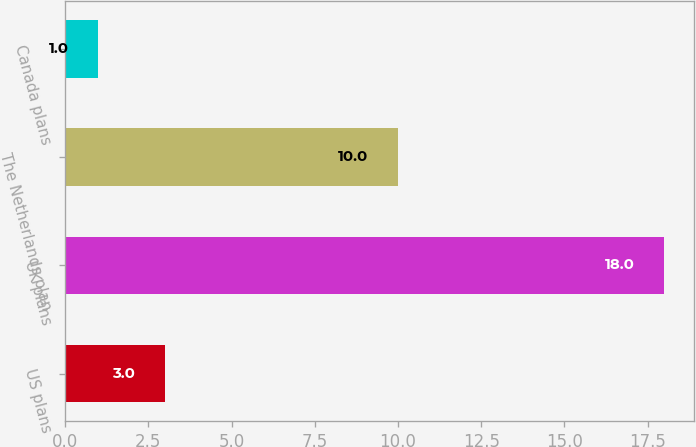Convert chart to OTSL. <chart><loc_0><loc_0><loc_500><loc_500><bar_chart><fcel>US plans<fcel>UK plans<fcel>The Netherlands plan<fcel>Canada plans<nl><fcel>3<fcel>18<fcel>10<fcel>1<nl></chart> 